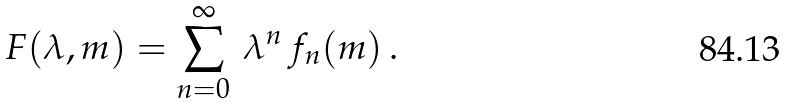<formula> <loc_0><loc_0><loc_500><loc_500>F ( \lambda , m ) = \sum _ { n = 0 } ^ { \infty } \, \lambda ^ { n } \, f _ { n } ( m ) \, .</formula> 